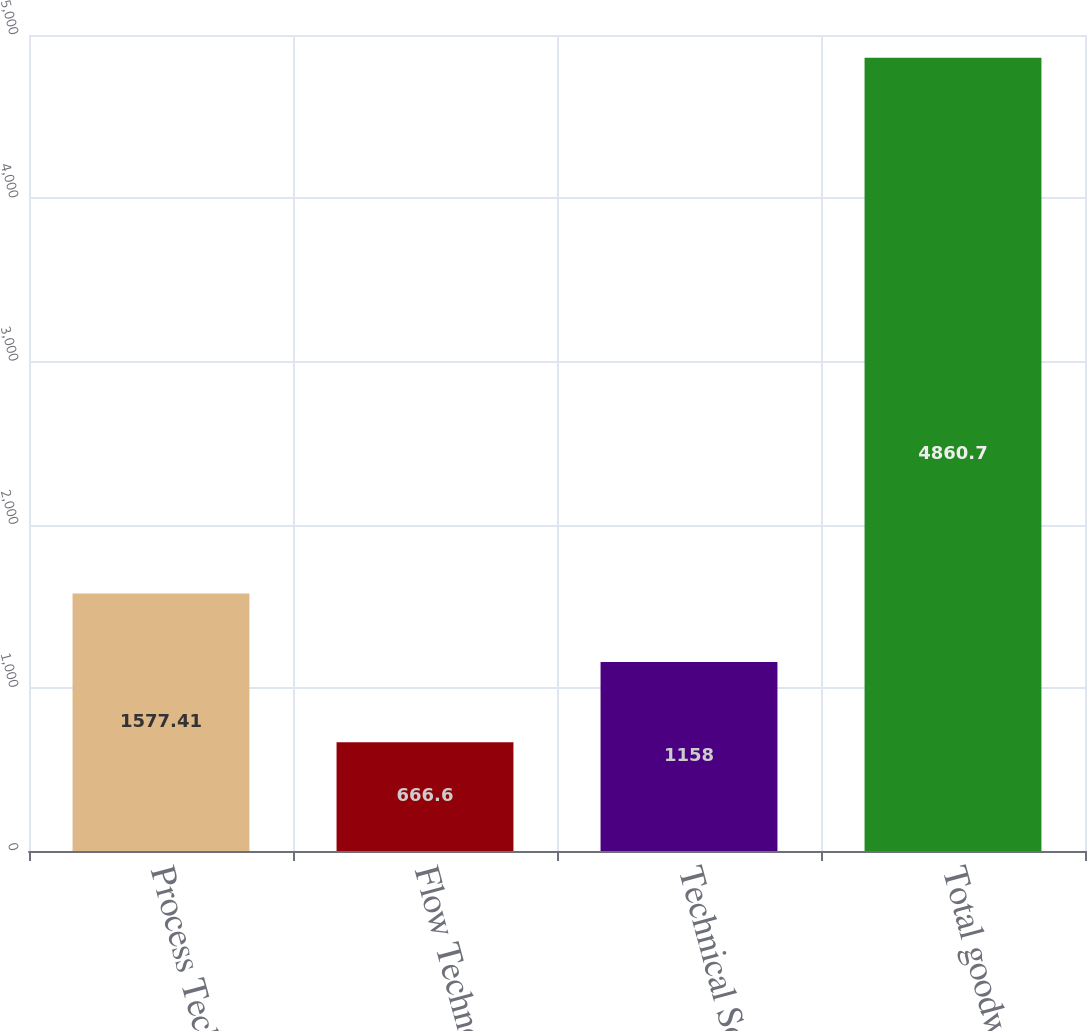Convert chart. <chart><loc_0><loc_0><loc_500><loc_500><bar_chart><fcel>Process Technologies<fcel>Flow Technologies<fcel>Technical Solutions<fcel>Total goodwill<nl><fcel>1577.41<fcel>666.6<fcel>1158<fcel>4860.7<nl></chart> 